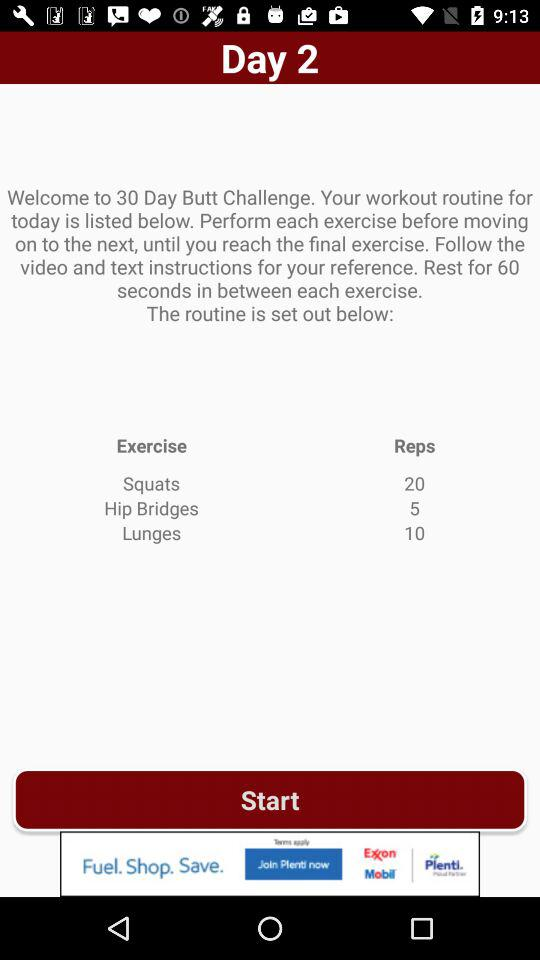What is the total number of reps for hip bridges? The total number of reps is 5. 